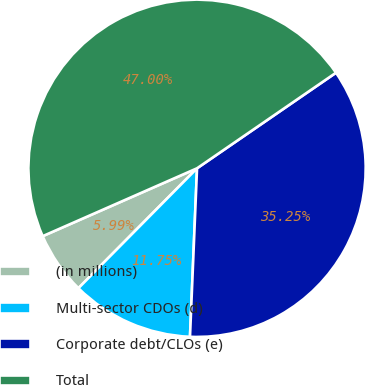Convert chart. <chart><loc_0><loc_0><loc_500><loc_500><pie_chart><fcel>(in millions)<fcel>Multi-sector CDOs (d)<fcel>Corporate debt/CLOs (e)<fcel>Total<nl><fcel>5.99%<fcel>11.75%<fcel>35.25%<fcel>47.0%<nl></chart> 